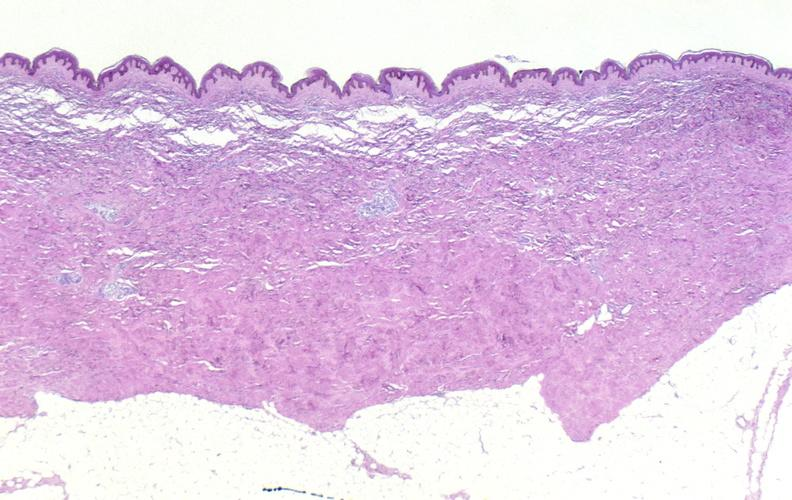does quite good liver show scleroderma?
Answer the question using a single word or phrase. No 